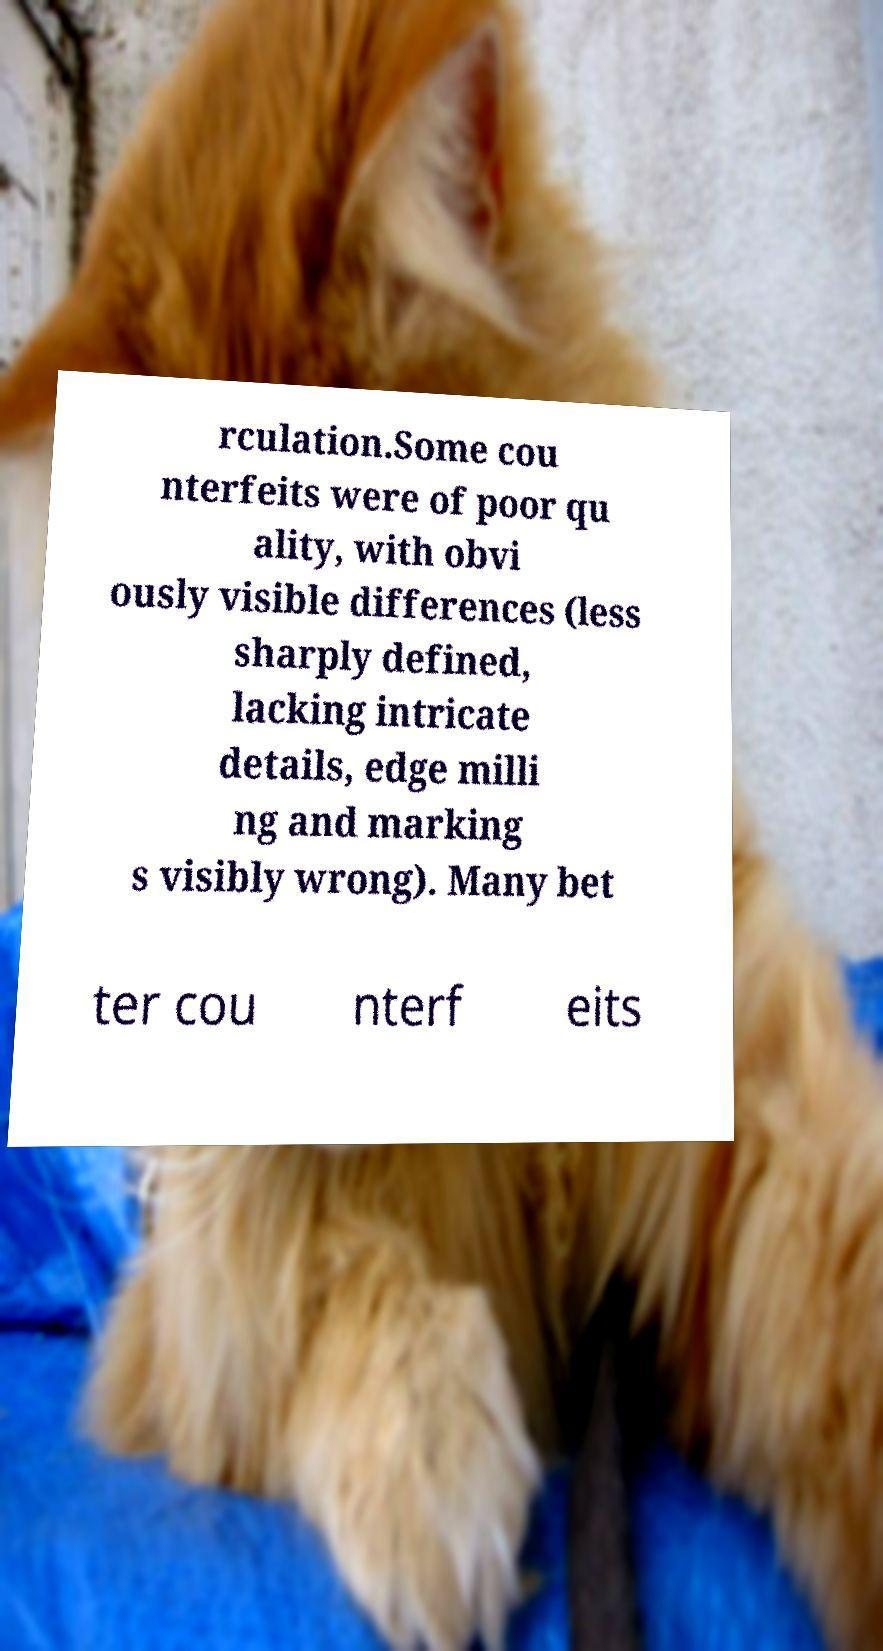I need the written content from this picture converted into text. Can you do that? rculation.Some cou nterfeits were of poor qu ality, with obvi ously visible differences (less sharply defined, lacking intricate details, edge milli ng and marking s visibly wrong). Many bet ter cou nterf eits 